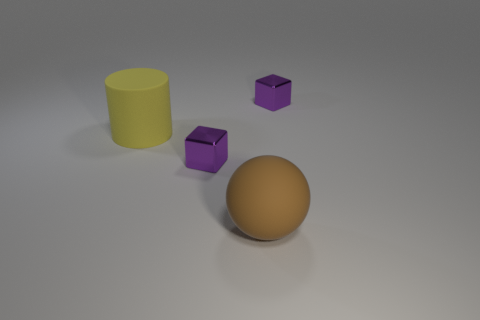Imagine these objects were part of a minimalist art piece; what title would you give it? If these objects were part of a minimalist art piece, a fitting title might be 'Simplicity in Form'. This title reflects the basic geometric shapes and the unadorned quality of the materials, emphasizing the beauty found in fundamental forms. Can you expand on the themes present in 'Simplicity in Form'? 'Simplicity in Form' could explore themes like the essence of objects, the interplay of light and shadow, and the idea that beauty and complexity need not be ostentatious, but can instead be found in the purest and simplest of designs. 